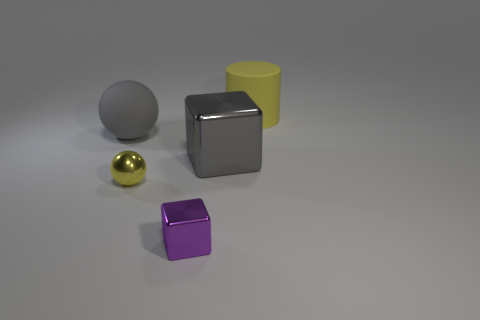What color is the small shiny object that is behind the small purple object? The small shiny object located behind the small purple cube is gold in color. It appears to have a reflective surface and stands out due to its metallic sheen. 